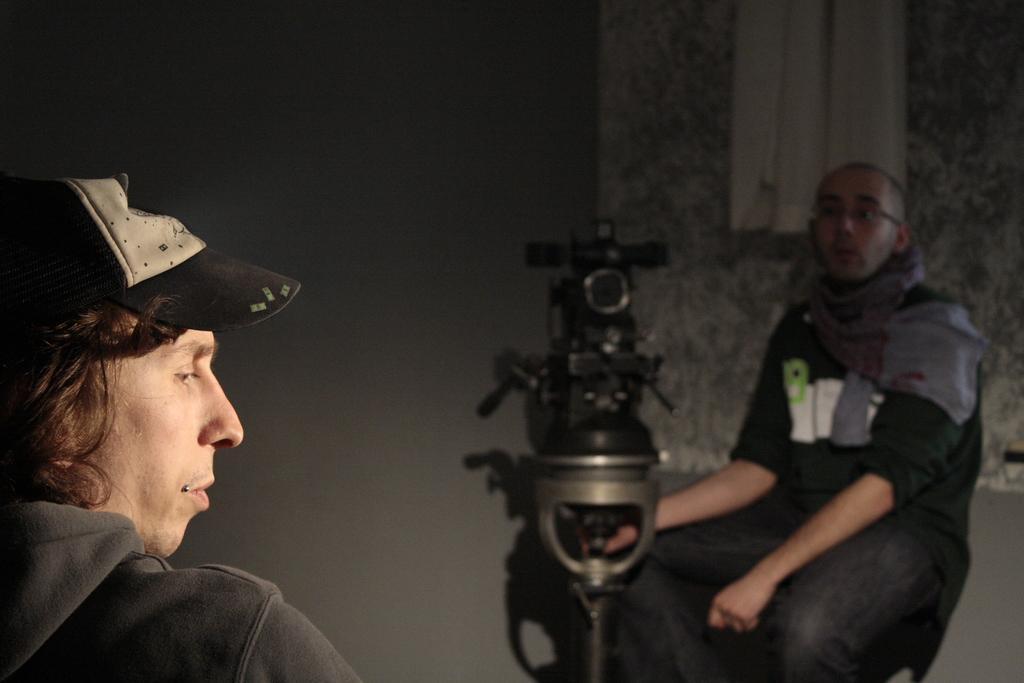In one or two sentences, can you explain what this image depicts? In the bottom left side of the image a person is sitting. In the bottom right side of the image a person is sitting and holding a camera. Behind him there is a wall. 